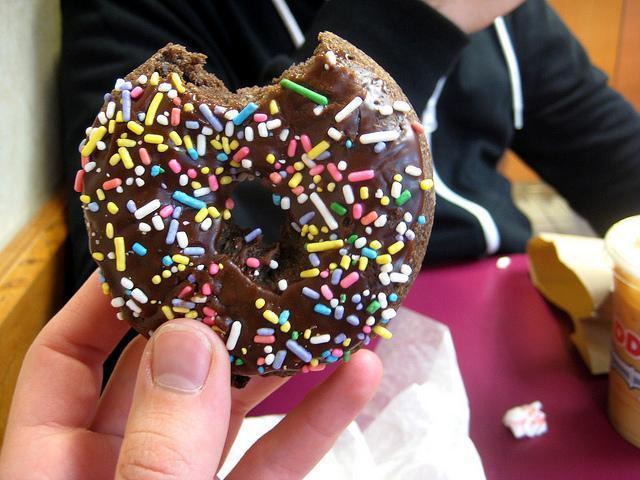How many donuts can be seen?
Give a very brief answer. 1. How many people are there?
Give a very brief answer. 2. 